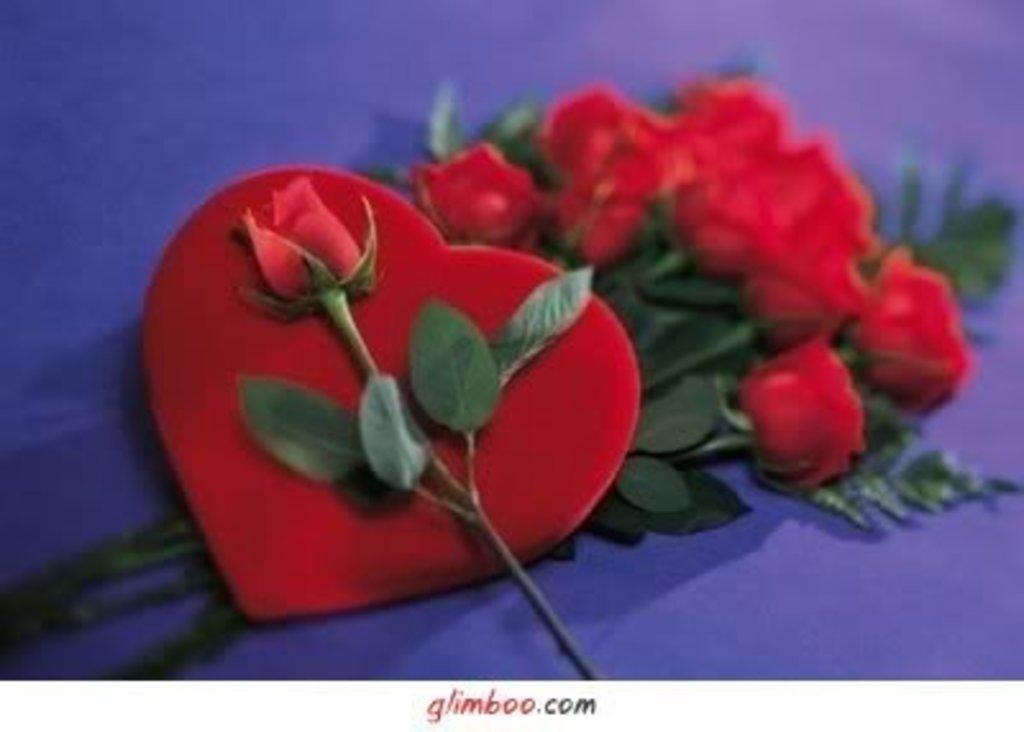Describe this image in one or two sentences. In this image we can see red roses, leaves and one heart shaped thing on purple surface. 